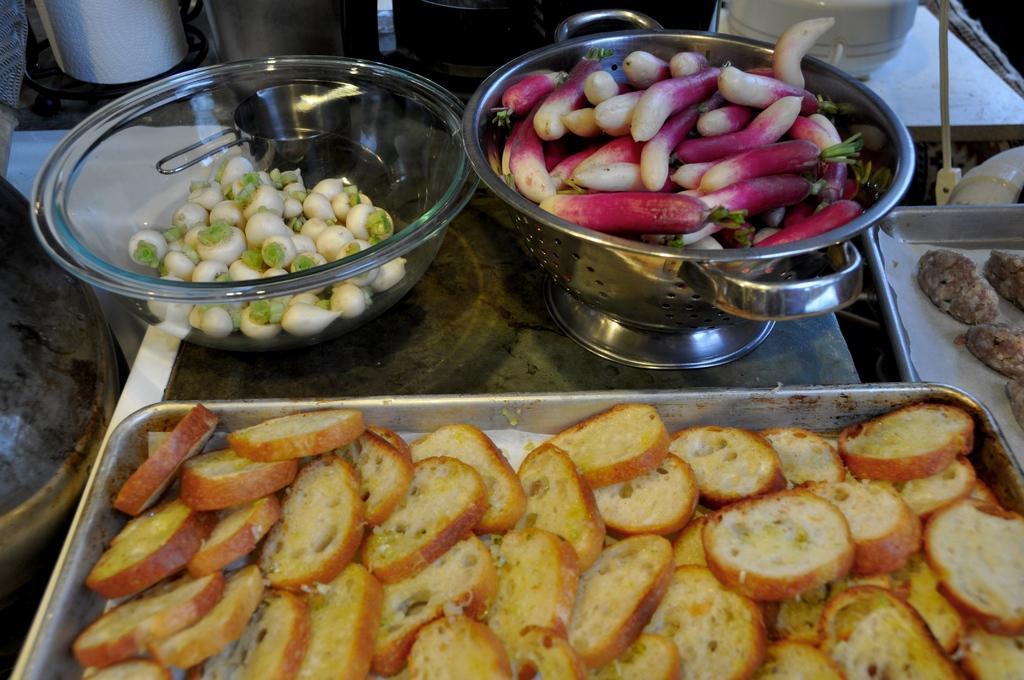Describe this image in one or two sentences. In this image we can see some pieces of bread and cookies in the trays, some spring onions and root vegetables in the bowls which are placed on the table. We can also see some containers beside them. 